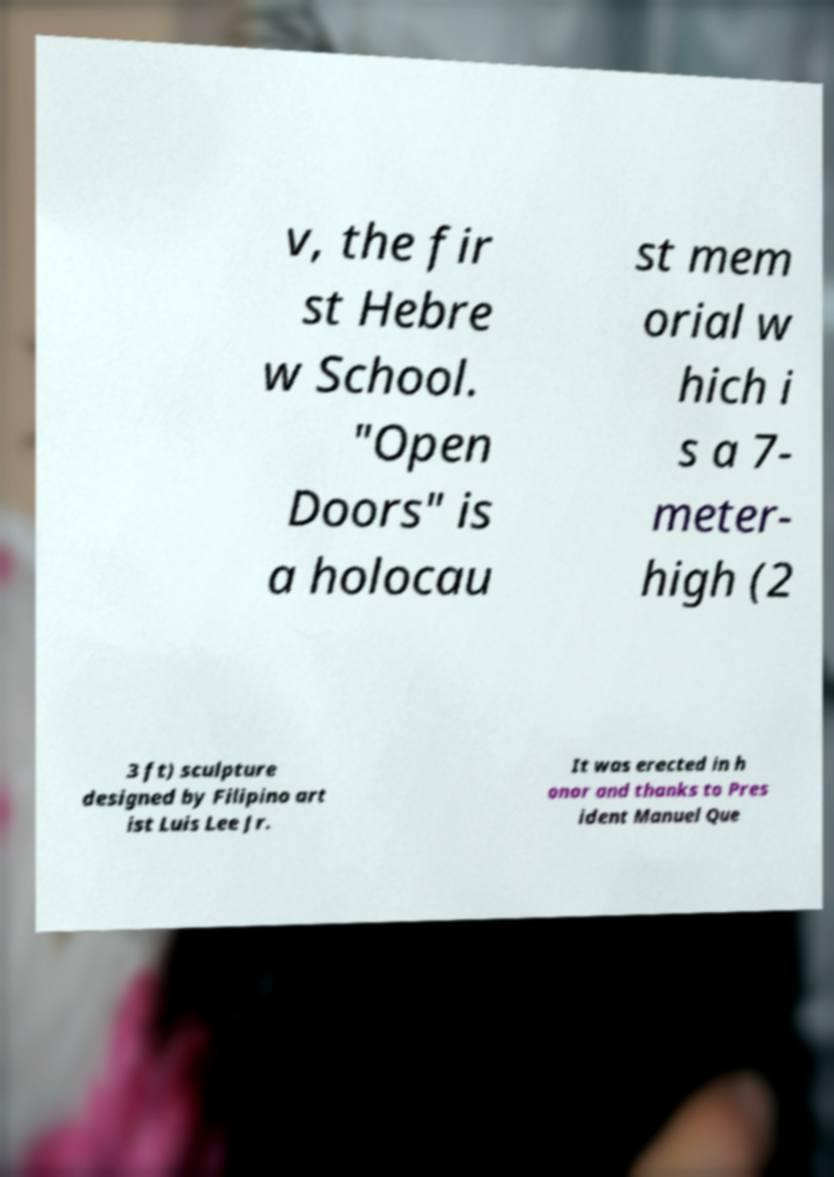What messages or text are displayed in this image? I need them in a readable, typed format. v, the fir st Hebre w School. "Open Doors" is a holocau st mem orial w hich i s a 7- meter- high (2 3 ft) sculpture designed by Filipino art ist Luis Lee Jr. It was erected in h onor and thanks to Pres ident Manuel Que 